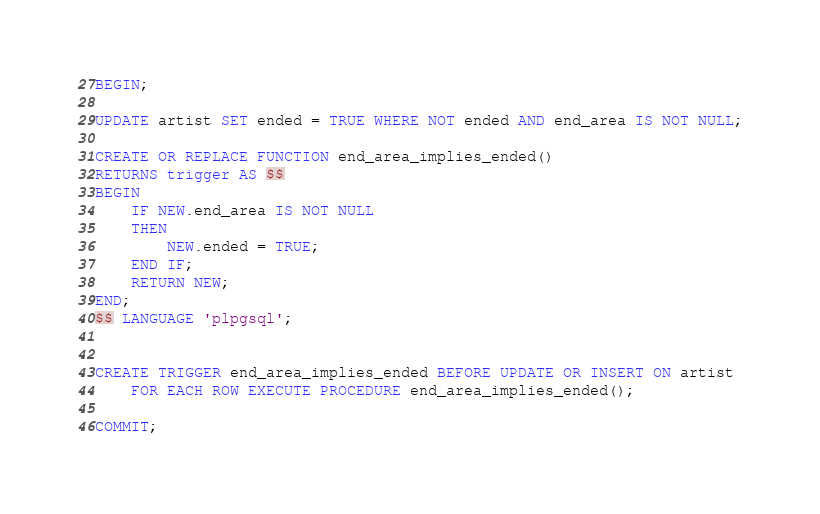Convert code to text. <code><loc_0><loc_0><loc_500><loc_500><_SQL_>BEGIN;

UPDATE artist SET ended = TRUE WHERE NOT ended AND end_area IS NOT NULL;

CREATE OR REPLACE FUNCTION end_area_implies_ended()
RETURNS trigger AS $$
BEGIN
    IF NEW.end_area IS NOT NULL
    THEN
        NEW.ended = TRUE;
    END IF;
    RETURN NEW;
END;
$$ LANGUAGE 'plpgsql';


CREATE TRIGGER end_area_implies_ended BEFORE UPDATE OR INSERT ON artist
    FOR EACH ROW EXECUTE PROCEDURE end_area_implies_ended();

COMMIT;
</code> 